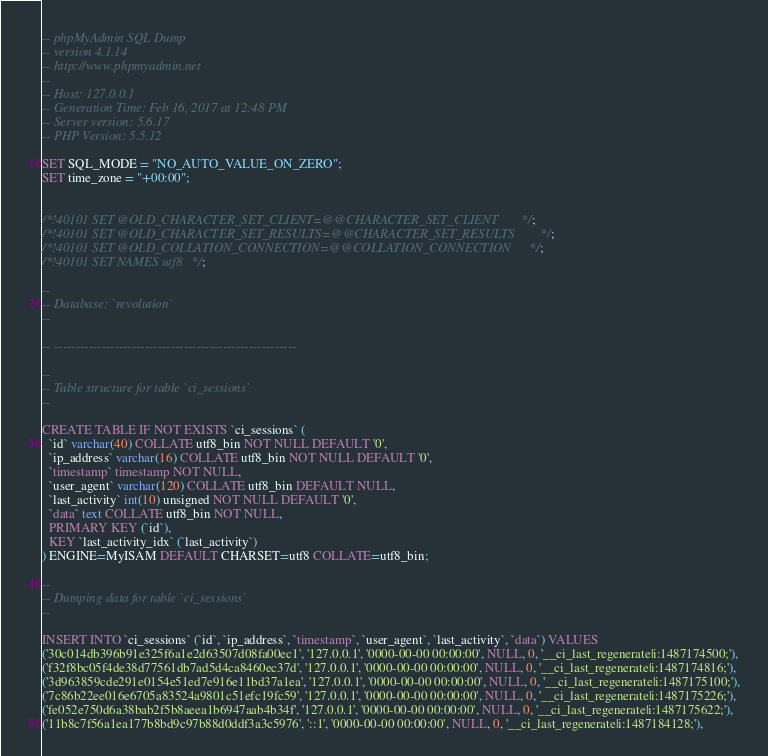Convert code to text. <code><loc_0><loc_0><loc_500><loc_500><_SQL_>-- phpMyAdmin SQL Dump
-- version 4.1.14
-- http://www.phpmyadmin.net
--
-- Host: 127.0.0.1
-- Generation Time: Feb 16, 2017 at 12:48 PM
-- Server version: 5.6.17
-- PHP Version: 5.5.12

SET SQL_MODE = "NO_AUTO_VALUE_ON_ZERO";
SET time_zone = "+00:00";


/*!40101 SET @OLD_CHARACTER_SET_CLIENT=@@CHARACTER_SET_CLIENT */;
/*!40101 SET @OLD_CHARACTER_SET_RESULTS=@@CHARACTER_SET_RESULTS */;
/*!40101 SET @OLD_COLLATION_CONNECTION=@@COLLATION_CONNECTION */;
/*!40101 SET NAMES utf8 */;

--
-- Database: `revolution`
--

-- --------------------------------------------------------

--
-- Table structure for table `ci_sessions`
--

CREATE TABLE IF NOT EXISTS `ci_sessions` (
  `id` varchar(40) COLLATE utf8_bin NOT NULL DEFAULT '0',
  `ip_address` varchar(16) COLLATE utf8_bin NOT NULL DEFAULT '0',
  `timestamp` timestamp NOT NULL,
  `user_agent` varchar(120) COLLATE utf8_bin DEFAULT NULL,
  `last_activity` int(10) unsigned NOT NULL DEFAULT '0',
  `data` text COLLATE utf8_bin NOT NULL,
  PRIMARY KEY (`id`),
  KEY `last_activity_idx` (`last_activity`)
) ENGINE=MyISAM DEFAULT CHARSET=utf8 COLLATE=utf8_bin;

--
-- Dumping data for table `ci_sessions`
--

INSERT INTO `ci_sessions` (`id`, `ip_address`, `timestamp`, `user_agent`, `last_activity`, `data`) VALUES
('30c014db396b91e325f6a1e2d63507d08fa00ec1', '127.0.0.1', '0000-00-00 00:00:00', NULL, 0, '__ci_last_regenerate|i:1487174500;'),
('f32f8bc05f4de38d77561db7ad5d4ca8460ec37d', '127.0.0.1', '0000-00-00 00:00:00', NULL, 0, '__ci_last_regenerate|i:1487174816;'),
('3d963859cde291e0154e51ed7e916e11bd37a1ea', '127.0.0.1', '0000-00-00 00:00:00', NULL, 0, '__ci_last_regenerate|i:1487175100;'),
('7c86b22ee016e6705a83524a9801c51efc19fc59', '127.0.0.1', '0000-00-00 00:00:00', NULL, 0, '__ci_last_regenerate|i:1487175226;'),
('fe052e750d6a38bab2f5b8aeea1b6947aab4b34f', '127.0.0.1', '0000-00-00 00:00:00', NULL, 0, '__ci_last_regenerate|i:1487175622;'),
('11b8c7f56a1ea177b8bd9c97b88d0ddf3a3c5976', '::1', '0000-00-00 00:00:00', NULL, 0, '__ci_last_regenerate|i:1487184128;'),</code> 